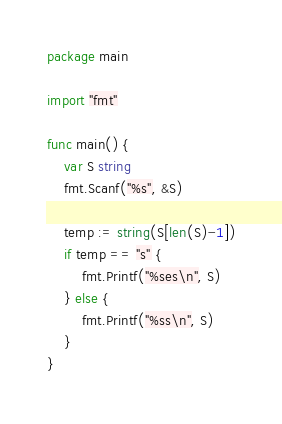Convert code to text. <code><loc_0><loc_0><loc_500><loc_500><_Go_>package main

import "fmt"

func main() {
	var S string
	fmt.Scanf("%s", &S)

	temp := string(S[len(S)-1])
	if temp == "s" {
		fmt.Printf("%ses\n", S)
	} else {
		fmt.Printf("%ss\n", S)
	}
}
</code> 